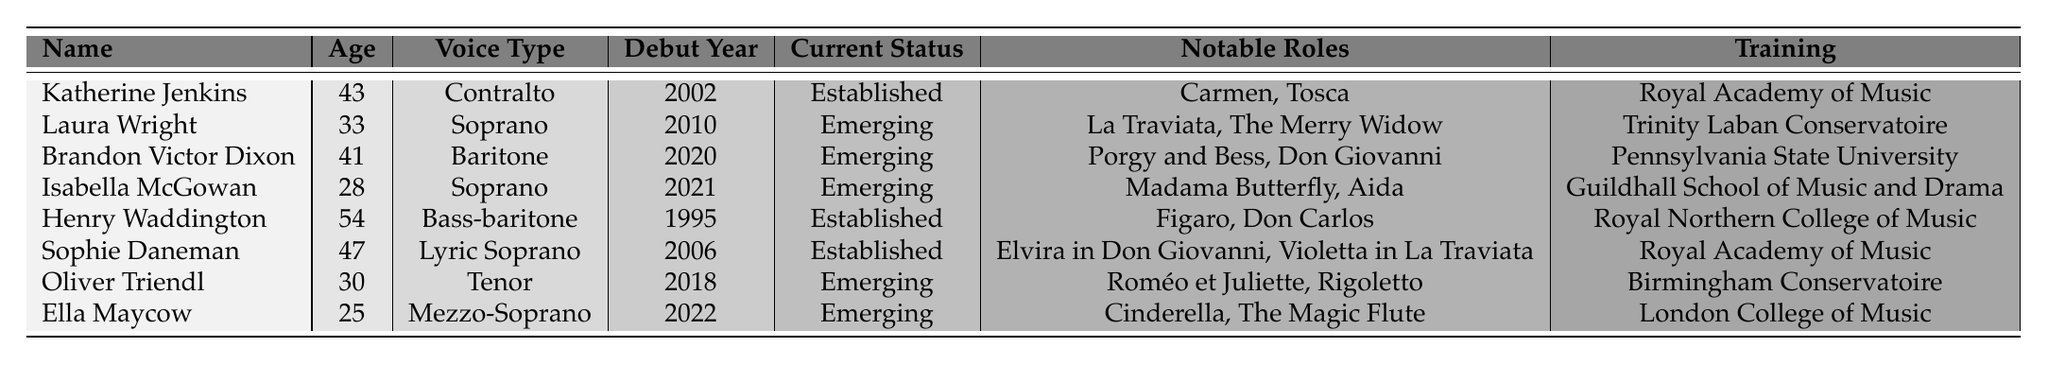What is the age of Isabella McGowan? To find Isabella McGowan's age, I look at the row with her name in the table. The age is listed as 28.
Answer: 28 How many singers are currently established? I count the entries in the "Current Status" column that state "Established". There are 3 singers: Katherine Jenkins, Henry Waddington, and Sophie Daneman.
Answer: 3 Which voice type does Ella Maycow have? I can find Ella Maycow's voice type by locating her name in the table and checking the corresponding column for voice type. It shows she is a Mezzo-Soprano.
Answer: Mezzo-Soprano Did Katherine Jenkins debut after 2000? I check Katherine Jenkins' debut year in the table, which is 2002. Since 2002 is after 2000, the statement is true.
Answer: Yes What are the notable roles of the emerging singer who debuted in 2021? To find this, I first look for the emerging singer who debuted in 2021, which is Isabella McGowan. I then check her notable roles listed in the table, which are Madama Butterfly and Aida.
Answer: Madama Butterfly, Aida How many years have passed since Henry Waddington's debut? First, I find his debut year, which is 1995. I then subtract that from the current year, 2023: 2023 - 1995 = 28.
Answer: 28 Which training institution is associated with Laura Wright? I can find Laura Wright's training by locating her row in the table and checking the corresponding training column. It shows she trained at Trinity Laban Conservatoire.
Answer: Trinity Laban Conservatoire What is the average age of the emerging opera singers? I identify the ages of the emerging singers: Laura Wright (33), Brandon Victor Dixon (41), Isabella McGowan (28), Oliver Triendl (30), and Ella Maycow (25). I add these ages: 33 + 41 + 28 + 30 + 25 = 157. There are 5 singers, so the average age is 157 / 5 = 31.4, which rounds to 31 for a simple answer.
Answer: 31 Is there an emerging singer who trained at the Royal Academy of Music? By reviewing the "Training" column for the emerging singers, I find that none of them trained at the Royal Academy of Music; therefore, the answer is no.
Answer: No What notable roles does the established singer with the highest age have? I identify the established singers and their ages: Katherine Jenkins (43), Henry Waddington (54), and Sophie Daneman (47). The highest age is 54, which corresponds to Henry Waddington. His notable roles are Figaro and Don Carlos.
Answer: Figaro, Don Carlos 